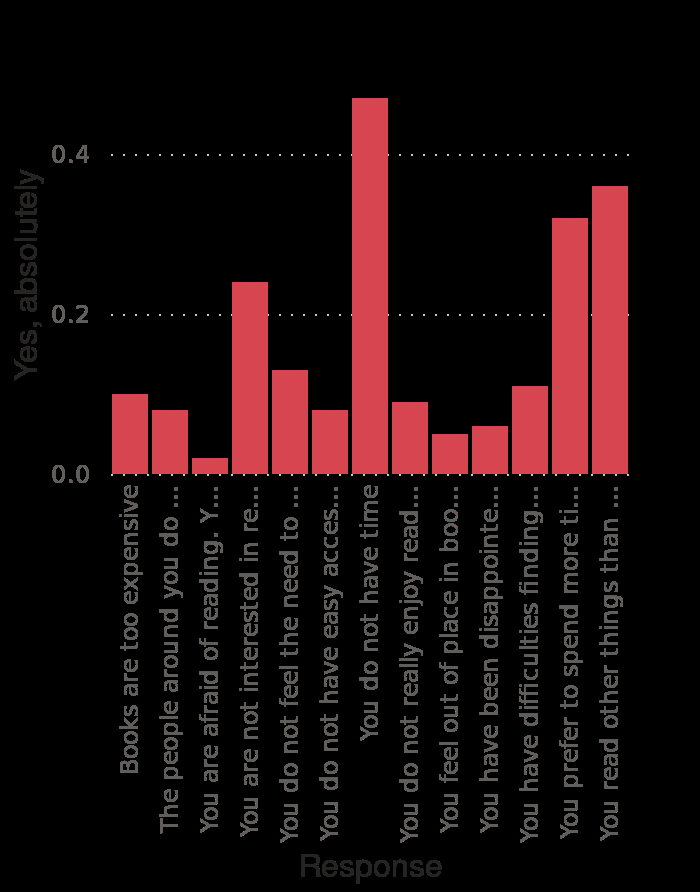<image>
What was the most common reason for people not reading books?  The most common reason for people not reading books was a lack of time. What does the high response rate for the fourth reason imply? The high response rate for the fourth reason implies that there is a potentially quite large market for readers who could be interested in the right circumstances with the right book. What does the x-axis of the bar diagram represent?  The x-axis of the bar diagram represents the reasons for not reading more books at the moment. 